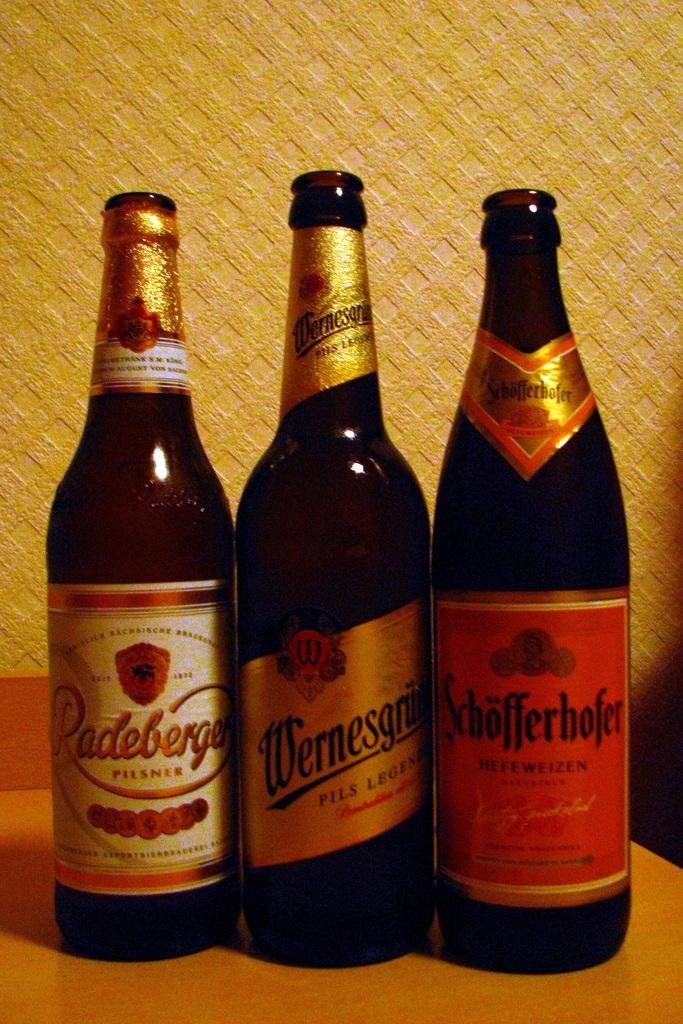<image>
Write a terse but informative summary of the picture. A bottle labeled Schofferhofer is lined up to the right of two other bottles. 